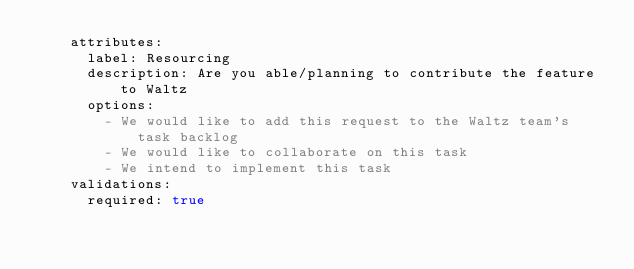Convert code to text. <code><loc_0><loc_0><loc_500><loc_500><_YAML_>    attributes:
      label: Resourcing
      description: Are you able/planning to contribute the feature to Waltz
      options:
        - We would like to add this request to the Waltz team's task backlog
        - We would like to collaborate on this task
        - We intend to implement this task
    validations:
      required: true
</code> 